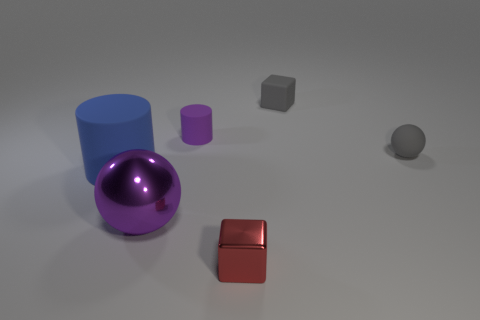What is the color of the matte cylinder that is to the right of the big ball?
Your answer should be very brief. Purple. Are there any tiny gray objects on the left side of the gray rubber ball behind the tiny red metallic cube?
Make the answer very short. Yes. Are there fewer tiny gray rubber cubes than big metal cubes?
Offer a very short reply. No. What is the material of the small block that is behind the cylinder that is in front of the tiny gray rubber ball?
Offer a very short reply. Rubber. Do the blue cylinder and the gray block have the same size?
Keep it short and to the point. No. What number of objects are small purple cylinders or gray things?
Your answer should be compact. 3. There is a thing that is behind the large shiny object and in front of the gray matte sphere; what size is it?
Your answer should be compact. Large. Are there fewer things behind the big blue rubber cylinder than blue rubber objects?
Make the answer very short. No. What is the shape of the tiny object that is made of the same material as the large purple sphere?
Your answer should be compact. Cube. Do the metal thing that is on the right side of the big metallic thing and the tiny gray thing that is to the left of the tiny gray sphere have the same shape?
Your response must be concise. Yes. 